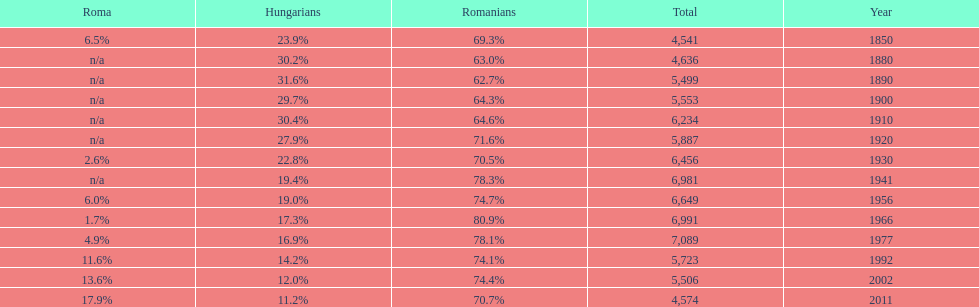What were the total number of times the romanians had a population percentage above 70%? 9. Parse the table in full. {'header': ['Roma', 'Hungarians', 'Romanians', 'Total', 'Year'], 'rows': [['6.5%', '23.9%', '69.3%', '4,541', '1850'], ['n/a', '30.2%', '63.0%', '4,636', '1880'], ['n/a', '31.6%', '62.7%', '5,499', '1890'], ['n/a', '29.7%', '64.3%', '5,553', '1900'], ['n/a', '30.4%', '64.6%', '6,234', '1910'], ['n/a', '27.9%', '71.6%', '5,887', '1920'], ['2.6%', '22.8%', '70.5%', '6,456', '1930'], ['n/a', '19.4%', '78.3%', '6,981', '1941'], ['6.0%', '19.0%', '74.7%', '6,649', '1956'], ['1.7%', '17.3%', '80.9%', '6,991', '1966'], ['4.9%', '16.9%', '78.1%', '7,089', '1977'], ['11.6%', '14.2%', '74.1%', '5,723', '1992'], ['13.6%', '12.0%', '74.4%', '5,506', '2002'], ['17.9%', '11.2%', '70.7%', '4,574', '2011']]} 